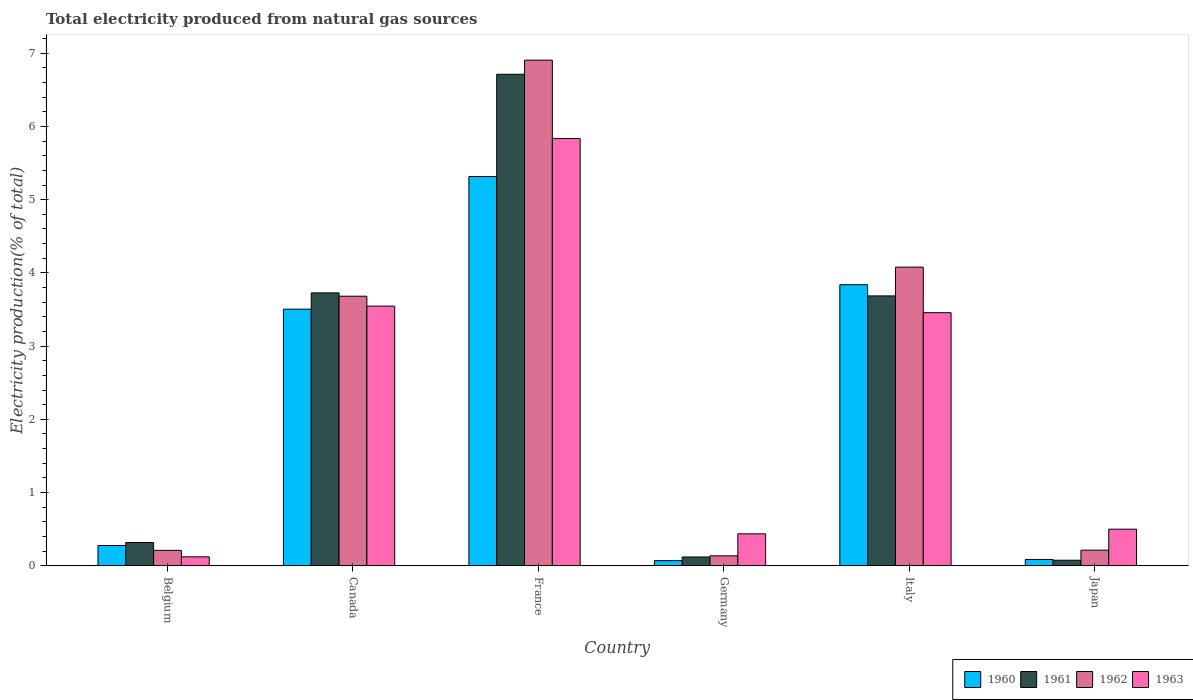How many different coloured bars are there?
Your response must be concise. 4. How many groups of bars are there?
Give a very brief answer. 6. Are the number of bars per tick equal to the number of legend labels?
Your answer should be compact. Yes. Are the number of bars on each tick of the X-axis equal?
Provide a short and direct response. Yes. How many bars are there on the 3rd tick from the left?
Your response must be concise. 4. What is the total electricity produced in 1963 in Canada?
Make the answer very short. 3.55. Across all countries, what is the maximum total electricity produced in 1960?
Your answer should be compact. 5.32. Across all countries, what is the minimum total electricity produced in 1960?
Offer a very short reply. 0.07. In which country was the total electricity produced in 1961 maximum?
Provide a short and direct response. France. In which country was the total electricity produced in 1963 minimum?
Provide a short and direct response. Belgium. What is the total total electricity produced in 1961 in the graph?
Keep it short and to the point. 14.64. What is the difference between the total electricity produced in 1962 in Belgium and that in Japan?
Ensure brevity in your answer.  -0. What is the difference between the total electricity produced in 1963 in Japan and the total electricity produced in 1962 in Germany?
Your answer should be compact. 0.36. What is the average total electricity produced in 1963 per country?
Keep it short and to the point. 2.32. What is the difference between the total electricity produced of/in 1963 and total electricity produced of/in 1961 in Italy?
Ensure brevity in your answer.  -0.23. What is the ratio of the total electricity produced in 1962 in Belgium to that in Japan?
Ensure brevity in your answer.  0.99. Is the total electricity produced in 1961 in Belgium less than that in Italy?
Give a very brief answer. Yes. What is the difference between the highest and the second highest total electricity produced in 1963?
Ensure brevity in your answer.  -0.09. What is the difference between the highest and the lowest total electricity produced in 1962?
Keep it short and to the point. 6.77. Is the sum of the total electricity produced in 1961 in Belgium and Germany greater than the maximum total electricity produced in 1962 across all countries?
Make the answer very short. No. What does the 4th bar from the right in Japan represents?
Your response must be concise. 1960. How many bars are there?
Give a very brief answer. 24. Are all the bars in the graph horizontal?
Offer a very short reply. No. How many countries are there in the graph?
Give a very brief answer. 6. Are the values on the major ticks of Y-axis written in scientific E-notation?
Make the answer very short. No. Where does the legend appear in the graph?
Your answer should be very brief. Bottom right. How many legend labels are there?
Keep it short and to the point. 4. How are the legend labels stacked?
Ensure brevity in your answer.  Horizontal. What is the title of the graph?
Provide a short and direct response. Total electricity produced from natural gas sources. What is the Electricity production(% of total) in 1960 in Belgium?
Provide a short and direct response. 0.28. What is the Electricity production(% of total) in 1961 in Belgium?
Your answer should be compact. 0.32. What is the Electricity production(% of total) in 1962 in Belgium?
Keep it short and to the point. 0.21. What is the Electricity production(% of total) in 1963 in Belgium?
Keep it short and to the point. 0.12. What is the Electricity production(% of total) of 1960 in Canada?
Keep it short and to the point. 3.5. What is the Electricity production(% of total) in 1961 in Canada?
Your answer should be compact. 3.73. What is the Electricity production(% of total) in 1962 in Canada?
Offer a very short reply. 3.68. What is the Electricity production(% of total) of 1963 in Canada?
Keep it short and to the point. 3.55. What is the Electricity production(% of total) of 1960 in France?
Provide a succinct answer. 5.32. What is the Electricity production(% of total) of 1961 in France?
Your answer should be very brief. 6.71. What is the Electricity production(% of total) of 1962 in France?
Provide a short and direct response. 6.91. What is the Electricity production(% of total) in 1963 in France?
Your answer should be compact. 5.83. What is the Electricity production(% of total) of 1960 in Germany?
Make the answer very short. 0.07. What is the Electricity production(% of total) of 1961 in Germany?
Your answer should be very brief. 0.12. What is the Electricity production(% of total) in 1962 in Germany?
Give a very brief answer. 0.14. What is the Electricity production(% of total) of 1963 in Germany?
Provide a short and direct response. 0.44. What is the Electricity production(% of total) of 1960 in Italy?
Your response must be concise. 3.84. What is the Electricity production(% of total) in 1961 in Italy?
Your response must be concise. 3.69. What is the Electricity production(% of total) in 1962 in Italy?
Provide a succinct answer. 4.08. What is the Electricity production(% of total) in 1963 in Italy?
Your answer should be compact. 3.46. What is the Electricity production(% of total) of 1960 in Japan?
Provide a short and direct response. 0.09. What is the Electricity production(% of total) in 1961 in Japan?
Ensure brevity in your answer.  0.08. What is the Electricity production(% of total) of 1962 in Japan?
Your answer should be compact. 0.21. What is the Electricity production(% of total) in 1963 in Japan?
Keep it short and to the point. 0.5. Across all countries, what is the maximum Electricity production(% of total) in 1960?
Make the answer very short. 5.32. Across all countries, what is the maximum Electricity production(% of total) of 1961?
Offer a terse response. 6.71. Across all countries, what is the maximum Electricity production(% of total) of 1962?
Provide a short and direct response. 6.91. Across all countries, what is the maximum Electricity production(% of total) of 1963?
Your answer should be compact. 5.83. Across all countries, what is the minimum Electricity production(% of total) in 1960?
Your response must be concise. 0.07. Across all countries, what is the minimum Electricity production(% of total) in 1961?
Keep it short and to the point. 0.08. Across all countries, what is the minimum Electricity production(% of total) of 1962?
Your answer should be compact. 0.14. Across all countries, what is the minimum Electricity production(% of total) in 1963?
Offer a very short reply. 0.12. What is the total Electricity production(% of total) of 1960 in the graph?
Provide a short and direct response. 13.09. What is the total Electricity production(% of total) of 1961 in the graph?
Offer a terse response. 14.64. What is the total Electricity production(% of total) of 1962 in the graph?
Keep it short and to the point. 15.23. What is the total Electricity production(% of total) in 1963 in the graph?
Your answer should be very brief. 13.9. What is the difference between the Electricity production(% of total) of 1960 in Belgium and that in Canada?
Provide a short and direct response. -3.23. What is the difference between the Electricity production(% of total) of 1961 in Belgium and that in Canada?
Give a very brief answer. -3.41. What is the difference between the Electricity production(% of total) of 1962 in Belgium and that in Canada?
Offer a terse response. -3.47. What is the difference between the Electricity production(% of total) in 1963 in Belgium and that in Canada?
Make the answer very short. -3.42. What is the difference between the Electricity production(% of total) in 1960 in Belgium and that in France?
Your response must be concise. -5.04. What is the difference between the Electricity production(% of total) in 1961 in Belgium and that in France?
Offer a terse response. -6.39. What is the difference between the Electricity production(% of total) in 1962 in Belgium and that in France?
Your answer should be very brief. -6.69. What is the difference between the Electricity production(% of total) of 1963 in Belgium and that in France?
Make the answer very short. -5.71. What is the difference between the Electricity production(% of total) in 1960 in Belgium and that in Germany?
Offer a terse response. 0.21. What is the difference between the Electricity production(% of total) in 1961 in Belgium and that in Germany?
Provide a succinct answer. 0.2. What is the difference between the Electricity production(% of total) of 1962 in Belgium and that in Germany?
Offer a very short reply. 0.07. What is the difference between the Electricity production(% of total) in 1963 in Belgium and that in Germany?
Your answer should be very brief. -0.31. What is the difference between the Electricity production(% of total) of 1960 in Belgium and that in Italy?
Provide a succinct answer. -3.56. What is the difference between the Electricity production(% of total) of 1961 in Belgium and that in Italy?
Ensure brevity in your answer.  -3.37. What is the difference between the Electricity production(% of total) in 1962 in Belgium and that in Italy?
Your answer should be very brief. -3.87. What is the difference between the Electricity production(% of total) of 1963 in Belgium and that in Italy?
Your answer should be very brief. -3.33. What is the difference between the Electricity production(% of total) of 1960 in Belgium and that in Japan?
Your answer should be compact. 0.19. What is the difference between the Electricity production(% of total) in 1961 in Belgium and that in Japan?
Offer a terse response. 0.24. What is the difference between the Electricity production(% of total) in 1962 in Belgium and that in Japan?
Provide a short and direct response. -0. What is the difference between the Electricity production(% of total) in 1963 in Belgium and that in Japan?
Your answer should be compact. -0.38. What is the difference between the Electricity production(% of total) in 1960 in Canada and that in France?
Give a very brief answer. -1.81. What is the difference between the Electricity production(% of total) in 1961 in Canada and that in France?
Make the answer very short. -2.99. What is the difference between the Electricity production(% of total) of 1962 in Canada and that in France?
Offer a very short reply. -3.22. What is the difference between the Electricity production(% of total) in 1963 in Canada and that in France?
Your answer should be compact. -2.29. What is the difference between the Electricity production(% of total) of 1960 in Canada and that in Germany?
Make the answer very short. 3.43. What is the difference between the Electricity production(% of total) of 1961 in Canada and that in Germany?
Keep it short and to the point. 3.61. What is the difference between the Electricity production(% of total) of 1962 in Canada and that in Germany?
Offer a terse response. 3.55. What is the difference between the Electricity production(% of total) of 1963 in Canada and that in Germany?
Ensure brevity in your answer.  3.11. What is the difference between the Electricity production(% of total) of 1960 in Canada and that in Italy?
Give a very brief answer. -0.33. What is the difference between the Electricity production(% of total) in 1961 in Canada and that in Italy?
Your answer should be very brief. 0.04. What is the difference between the Electricity production(% of total) of 1962 in Canada and that in Italy?
Keep it short and to the point. -0.4. What is the difference between the Electricity production(% of total) of 1963 in Canada and that in Italy?
Provide a short and direct response. 0.09. What is the difference between the Electricity production(% of total) in 1960 in Canada and that in Japan?
Give a very brief answer. 3.42. What is the difference between the Electricity production(% of total) in 1961 in Canada and that in Japan?
Make the answer very short. 3.65. What is the difference between the Electricity production(% of total) in 1962 in Canada and that in Japan?
Give a very brief answer. 3.47. What is the difference between the Electricity production(% of total) of 1963 in Canada and that in Japan?
Offer a very short reply. 3.05. What is the difference between the Electricity production(% of total) in 1960 in France and that in Germany?
Make the answer very short. 5.25. What is the difference between the Electricity production(% of total) in 1961 in France and that in Germany?
Your answer should be compact. 6.59. What is the difference between the Electricity production(% of total) of 1962 in France and that in Germany?
Offer a terse response. 6.77. What is the difference between the Electricity production(% of total) of 1963 in France and that in Germany?
Offer a very short reply. 5.4. What is the difference between the Electricity production(% of total) of 1960 in France and that in Italy?
Provide a short and direct response. 1.48. What is the difference between the Electricity production(% of total) of 1961 in France and that in Italy?
Your answer should be very brief. 3.03. What is the difference between the Electricity production(% of total) in 1962 in France and that in Italy?
Offer a very short reply. 2.83. What is the difference between the Electricity production(% of total) in 1963 in France and that in Italy?
Offer a terse response. 2.38. What is the difference between the Electricity production(% of total) in 1960 in France and that in Japan?
Provide a short and direct response. 5.23. What is the difference between the Electricity production(% of total) of 1961 in France and that in Japan?
Give a very brief answer. 6.64. What is the difference between the Electricity production(% of total) in 1962 in France and that in Japan?
Your answer should be compact. 6.69. What is the difference between the Electricity production(% of total) of 1963 in France and that in Japan?
Offer a very short reply. 5.33. What is the difference between the Electricity production(% of total) in 1960 in Germany and that in Italy?
Your answer should be very brief. -3.77. What is the difference between the Electricity production(% of total) in 1961 in Germany and that in Italy?
Offer a very short reply. -3.57. What is the difference between the Electricity production(% of total) of 1962 in Germany and that in Italy?
Give a very brief answer. -3.94. What is the difference between the Electricity production(% of total) of 1963 in Germany and that in Italy?
Ensure brevity in your answer.  -3.02. What is the difference between the Electricity production(% of total) of 1960 in Germany and that in Japan?
Offer a very short reply. -0.02. What is the difference between the Electricity production(% of total) of 1961 in Germany and that in Japan?
Your answer should be compact. 0.04. What is the difference between the Electricity production(% of total) in 1962 in Germany and that in Japan?
Ensure brevity in your answer.  -0.08. What is the difference between the Electricity production(% of total) of 1963 in Germany and that in Japan?
Offer a terse response. -0.06. What is the difference between the Electricity production(% of total) in 1960 in Italy and that in Japan?
Make the answer very short. 3.75. What is the difference between the Electricity production(% of total) in 1961 in Italy and that in Japan?
Keep it short and to the point. 3.61. What is the difference between the Electricity production(% of total) of 1962 in Italy and that in Japan?
Provide a short and direct response. 3.86. What is the difference between the Electricity production(% of total) in 1963 in Italy and that in Japan?
Offer a very short reply. 2.96. What is the difference between the Electricity production(% of total) in 1960 in Belgium and the Electricity production(% of total) in 1961 in Canada?
Keep it short and to the point. -3.45. What is the difference between the Electricity production(% of total) of 1960 in Belgium and the Electricity production(% of total) of 1962 in Canada?
Offer a terse response. -3.4. What is the difference between the Electricity production(% of total) of 1960 in Belgium and the Electricity production(% of total) of 1963 in Canada?
Your answer should be very brief. -3.27. What is the difference between the Electricity production(% of total) of 1961 in Belgium and the Electricity production(% of total) of 1962 in Canada?
Make the answer very short. -3.36. What is the difference between the Electricity production(% of total) of 1961 in Belgium and the Electricity production(% of total) of 1963 in Canada?
Give a very brief answer. -3.23. What is the difference between the Electricity production(% of total) in 1962 in Belgium and the Electricity production(% of total) in 1963 in Canada?
Provide a short and direct response. -3.34. What is the difference between the Electricity production(% of total) of 1960 in Belgium and the Electricity production(% of total) of 1961 in France?
Your answer should be very brief. -6.43. What is the difference between the Electricity production(% of total) in 1960 in Belgium and the Electricity production(% of total) in 1962 in France?
Your answer should be very brief. -6.63. What is the difference between the Electricity production(% of total) of 1960 in Belgium and the Electricity production(% of total) of 1963 in France?
Provide a succinct answer. -5.56. What is the difference between the Electricity production(% of total) of 1961 in Belgium and the Electricity production(% of total) of 1962 in France?
Give a very brief answer. -6.59. What is the difference between the Electricity production(% of total) of 1961 in Belgium and the Electricity production(% of total) of 1963 in France?
Your answer should be compact. -5.52. What is the difference between the Electricity production(% of total) in 1962 in Belgium and the Electricity production(% of total) in 1963 in France?
Ensure brevity in your answer.  -5.62. What is the difference between the Electricity production(% of total) of 1960 in Belgium and the Electricity production(% of total) of 1961 in Germany?
Your response must be concise. 0.16. What is the difference between the Electricity production(% of total) in 1960 in Belgium and the Electricity production(% of total) in 1962 in Germany?
Your answer should be very brief. 0.14. What is the difference between the Electricity production(% of total) of 1960 in Belgium and the Electricity production(% of total) of 1963 in Germany?
Your answer should be compact. -0.16. What is the difference between the Electricity production(% of total) in 1961 in Belgium and the Electricity production(% of total) in 1962 in Germany?
Offer a very short reply. 0.18. What is the difference between the Electricity production(% of total) in 1961 in Belgium and the Electricity production(% of total) in 1963 in Germany?
Make the answer very short. -0.12. What is the difference between the Electricity production(% of total) of 1962 in Belgium and the Electricity production(% of total) of 1963 in Germany?
Your answer should be very brief. -0.23. What is the difference between the Electricity production(% of total) in 1960 in Belgium and the Electricity production(% of total) in 1961 in Italy?
Ensure brevity in your answer.  -3.41. What is the difference between the Electricity production(% of total) in 1960 in Belgium and the Electricity production(% of total) in 1962 in Italy?
Make the answer very short. -3.8. What is the difference between the Electricity production(% of total) of 1960 in Belgium and the Electricity production(% of total) of 1963 in Italy?
Make the answer very short. -3.18. What is the difference between the Electricity production(% of total) of 1961 in Belgium and the Electricity production(% of total) of 1962 in Italy?
Keep it short and to the point. -3.76. What is the difference between the Electricity production(% of total) in 1961 in Belgium and the Electricity production(% of total) in 1963 in Italy?
Your response must be concise. -3.14. What is the difference between the Electricity production(% of total) in 1962 in Belgium and the Electricity production(% of total) in 1963 in Italy?
Make the answer very short. -3.25. What is the difference between the Electricity production(% of total) in 1960 in Belgium and the Electricity production(% of total) in 1961 in Japan?
Give a very brief answer. 0.2. What is the difference between the Electricity production(% of total) in 1960 in Belgium and the Electricity production(% of total) in 1962 in Japan?
Offer a terse response. 0.06. What is the difference between the Electricity production(% of total) of 1960 in Belgium and the Electricity production(% of total) of 1963 in Japan?
Make the answer very short. -0.22. What is the difference between the Electricity production(% of total) of 1961 in Belgium and the Electricity production(% of total) of 1962 in Japan?
Give a very brief answer. 0.1. What is the difference between the Electricity production(% of total) of 1961 in Belgium and the Electricity production(% of total) of 1963 in Japan?
Your response must be concise. -0.18. What is the difference between the Electricity production(% of total) of 1962 in Belgium and the Electricity production(% of total) of 1963 in Japan?
Make the answer very short. -0.29. What is the difference between the Electricity production(% of total) of 1960 in Canada and the Electricity production(% of total) of 1961 in France?
Your response must be concise. -3.21. What is the difference between the Electricity production(% of total) in 1960 in Canada and the Electricity production(% of total) in 1962 in France?
Offer a very short reply. -3.4. What is the difference between the Electricity production(% of total) in 1960 in Canada and the Electricity production(% of total) in 1963 in France?
Your answer should be compact. -2.33. What is the difference between the Electricity production(% of total) of 1961 in Canada and the Electricity production(% of total) of 1962 in France?
Your answer should be compact. -3.18. What is the difference between the Electricity production(% of total) of 1961 in Canada and the Electricity production(% of total) of 1963 in France?
Ensure brevity in your answer.  -2.11. What is the difference between the Electricity production(% of total) of 1962 in Canada and the Electricity production(% of total) of 1963 in France?
Provide a short and direct response. -2.15. What is the difference between the Electricity production(% of total) in 1960 in Canada and the Electricity production(% of total) in 1961 in Germany?
Make the answer very short. 3.38. What is the difference between the Electricity production(% of total) of 1960 in Canada and the Electricity production(% of total) of 1962 in Germany?
Provide a short and direct response. 3.37. What is the difference between the Electricity production(% of total) of 1960 in Canada and the Electricity production(% of total) of 1963 in Germany?
Your answer should be very brief. 3.07. What is the difference between the Electricity production(% of total) in 1961 in Canada and the Electricity production(% of total) in 1962 in Germany?
Give a very brief answer. 3.59. What is the difference between the Electricity production(% of total) in 1961 in Canada and the Electricity production(% of total) in 1963 in Germany?
Keep it short and to the point. 3.29. What is the difference between the Electricity production(% of total) of 1962 in Canada and the Electricity production(% of total) of 1963 in Germany?
Keep it short and to the point. 3.25. What is the difference between the Electricity production(% of total) of 1960 in Canada and the Electricity production(% of total) of 1961 in Italy?
Keep it short and to the point. -0.18. What is the difference between the Electricity production(% of total) in 1960 in Canada and the Electricity production(% of total) in 1962 in Italy?
Offer a terse response. -0.57. What is the difference between the Electricity production(% of total) of 1960 in Canada and the Electricity production(% of total) of 1963 in Italy?
Keep it short and to the point. 0.05. What is the difference between the Electricity production(% of total) in 1961 in Canada and the Electricity production(% of total) in 1962 in Italy?
Your answer should be very brief. -0.35. What is the difference between the Electricity production(% of total) of 1961 in Canada and the Electricity production(% of total) of 1963 in Italy?
Ensure brevity in your answer.  0.27. What is the difference between the Electricity production(% of total) in 1962 in Canada and the Electricity production(% of total) in 1963 in Italy?
Offer a terse response. 0.23. What is the difference between the Electricity production(% of total) of 1960 in Canada and the Electricity production(% of total) of 1961 in Japan?
Provide a succinct answer. 3.43. What is the difference between the Electricity production(% of total) in 1960 in Canada and the Electricity production(% of total) in 1962 in Japan?
Make the answer very short. 3.29. What is the difference between the Electricity production(% of total) of 1960 in Canada and the Electricity production(% of total) of 1963 in Japan?
Ensure brevity in your answer.  3. What is the difference between the Electricity production(% of total) in 1961 in Canada and the Electricity production(% of total) in 1962 in Japan?
Your answer should be compact. 3.51. What is the difference between the Electricity production(% of total) of 1961 in Canada and the Electricity production(% of total) of 1963 in Japan?
Provide a short and direct response. 3.23. What is the difference between the Electricity production(% of total) in 1962 in Canada and the Electricity production(% of total) in 1963 in Japan?
Keep it short and to the point. 3.18. What is the difference between the Electricity production(% of total) in 1960 in France and the Electricity production(% of total) in 1961 in Germany?
Your response must be concise. 5.2. What is the difference between the Electricity production(% of total) of 1960 in France and the Electricity production(% of total) of 1962 in Germany?
Provide a short and direct response. 5.18. What is the difference between the Electricity production(% of total) of 1960 in France and the Electricity production(% of total) of 1963 in Germany?
Your response must be concise. 4.88. What is the difference between the Electricity production(% of total) of 1961 in France and the Electricity production(% of total) of 1962 in Germany?
Your answer should be very brief. 6.58. What is the difference between the Electricity production(% of total) of 1961 in France and the Electricity production(% of total) of 1963 in Germany?
Give a very brief answer. 6.28. What is the difference between the Electricity production(% of total) of 1962 in France and the Electricity production(% of total) of 1963 in Germany?
Provide a succinct answer. 6.47. What is the difference between the Electricity production(% of total) of 1960 in France and the Electricity production(% of total) of 1961 in Italy?
Provide a short and direct response. 1.63. What is the difference between the Electricity production(% of total) in 1960 in France and the Electricity production(% of total) in 1962 in Italy?
Ensure brevity in your answer.  1.24. What is the difference between the Electricity production(% of total) of 1960 in France and the Electricity production(% of total) of 1963 in Italy?
Give a very brief answer. 1.86. What is the difference between the Electricity production(% of total) of 1961 in France and the Electricity production(% of total) of 1962 in Italy?
Ensure brevity in your answer.  2.63. What is the difference between the Electricity production(% of total) in 1961 in France and the Electricity production(% of total) in 1963 in Italy?
Your answer should be compact. 3.26. What is the difference between the Electricity production(% of total) of 1962 in France and the Electricity production(% of total) of 1963 in Italy?
Keep it short and to the point. 3.45. What is the difference between the Electricity production(% of total) in 1960 in France and the Electricity production(% of total) in 1961 in Japan?
Make the answer very short. 5.24. What is the difference between the Electricity production(% of total) of 1960 in France and the Electricity production(% of total) of 1962 in Japan?
Offer a terse response. 5.1. What is the difference between the Electricity production(% of total) of 1960 in France and the Electricity production(% of total) of 1963 in Japan?
Your answer should be very brief. 4.82. What is the difference between the Electricity production(% of total) in 1961 in France and the Electricity production(% of total) in 1962 in Japan?
Your answer should be compact. 6.5. What is the difference between the Electricity production(% of total) of 1961 in France and the Electricity production(% of total) of 1963 in Japan?
Your answer should be very brief. 6.21. What is the difference between the Electricity production(% of total) in 1962 in France and the Electricity production(% of total) in 1963 in Japan?
Your answer should be very brief. 6.4. What is the difference between the Electricity production(% of total) in 1960 in Germany and the Electricity production(% of total) in 1961 in Italy?
Your response must be concise. -3.62. What is the difference between the Electricity production(% of total) in 1960 in Germany and the Electricity production(% of total) in 1962 in Italy?
Give a very brief answer. -4.01. What is the difference between the Electricity production(% of total) of 1960 in Germany and the Electricity production(% of total) of 1963 in Italy?
Offer a very short reply. -3.39. What is the difference between the Electricity production(% of total) in 1961 in Germany and the Electricity production(% of total) in 1962 in Italy?
Offer a very short reply. -3.96. What is the difference between the Electricity production(% of total) of 1961 in Germany and the Electricity production(% of total) of 1963 in Italy?
Offer a very short reply. -3.34. What is the difference between the Electricity production(% of total) of 1962 in Germany and the Electricity production(% of total) of 1963 in Italy?
Offer a terse response. -3.32. What is the difference between the Electricity production(% of total) of 1960 in Germany and the Electricity production(% of total) of 1961 in Japan?
Your response must be concise. -0.01. What is the difference between the Electricity production(% of total) in 1960 in Germany and the Electricity production(% of total) in 1962 in Japan?
Ensure brevity in your answer.  -0.14. What is the difference between the Electricity production(% of total) in 1960 in Germany and the Electricity production(% of total) in 1963 in Japan?
Give a very brief answer. -0.43. What is the difference between the Electricity production(% of total) in 1961 in Germany and the Electricity production(% of total) in 1962 in Japan?
Ensure brevity in your answer.  -0.09. What is the difference between the Electricity production(% of total) in 1961 in Germany and the Electricity production(% of total) in 1963 in Japan?
Ensure brevity in your answer.  -0.38. What is the difference between the Electricity production(% of total) of 1962 in Germany and the Electricity production(% of total) of 1963 in Japan?
Provide a succinct answer. -0.36. What is the difference between the Electricity production(% of total) in 1960 in Italy and the Electricity production(% of total) in 1961 in Japan?
Provide a short and direct response. 3.76. What is the difference between the Electricity production(% of total) of 1960 in Italy and the Electricity production(% of total) of 1962 in Japan?
Your answer should be compact. 3.62. What is the difference between the Electricity production(% of total) in 1960 in Italy and the Electricity production(% of total) in 1963 in Japan?
Your response must be concise. 3.34. What is the difference between the Electricity production(% of total) of 1961 in Italy and the Electricity production(% of total) of 1962 in Japan?
Keep it short and to the point. 3.47. What is the difference between the Electricity production(% of total) in 1961 in Italy and the Electricity production(% of total) in 1963 in Japan?
Provide a succinct answer. 3.19. What is the difference between the Electricity production(% of total) in 1962 in Italy and the Electricity production(% of total) in 1963 in Japan?
Make the answer very short. 3.58. What is the average Electricity production(% of total) in 1960 per country?
Offer a very short reply. 2.18. What is the average Electricity production(% of total) in 1961 per country?
Your answer should be compact. 2.44. What is the average Electricity production(% of total) of 1962 per country?
Your response must be concise. 2.54. What is the average Electricity production(% of total) of 1963 per country?
Make the answer very short. 2.32. What is the difference between the Electricity production(% of total) in 1960 and Electricity production(% of total) in 1961 in Belgium?
Make the answer very short. -0.04. What is the difference between the Electricity production(% of total) in 1960 and Electricity production(% of total) in 1962 in Belgium?
Provide a succinct answer. 0.07. What is the difference between the Electricity production(% of total) of 1960 and Electricity production(% of total) of 1963 in Belgium?
Your answer should be very brief. 0.15. What is the difference between the Electricity production(% of total) of 1961 and Electricity production(% of total) of 1962 in Belgium?
Your response must be concise. 0.11. What is the difference between the Electricity production(% of total) in 1961 and Electricity production(% of total) in 1963 in Belgium?
Provide a short and direct response. 0.2. What is the difference between the Electricity production(% of total) of 1962 and Electricity production(% of total) of 1963 in Belgium?
Make the answer very short. 0.09. What is the difference between the Electricity production(% of total) in 1960 and Electricity production(% of total) in 1961 in Canada?
Ensure brevity in your answer.  -0.22. What is the difference between the Electricity production(% of total) in 1960 and Electricity production(% of total) in 1962 in Canada?
Provide a succinct answer. -0.18. What is the difference between the Electricity production(% of total) in 1960 and Electricity production(% of total) in 1963 in Canada?
Provide a short and direct response. -0.04. What is the difference between the Electricity production(% of total) in 1961 and Electricity production(% of total) in 1962 in Canada?
Offer a terse response. 0.05. What is the difference between the Electricity production(% of total) in 1961 and Electricity production(% of total) in 1963 in Canada?
Offer a very short reply. 0.18. What is the difference between the Electricity production(% of total) of 1962 and Electricity production(% of total) of 1963 in Canada?
Give a very brief answer. 0.14. What is the difference between the Electricity production(% of total) in 1960 and Electricity production(% of total) in 1961 in France?
Offer a very short reply. -1.4. What is the difference between the Electricity production(% of total) of 1960 and Electricity production(% of total) of 1962 in France?
Give a very brief answer. -1.59. What is the difference between the Electricity production(% of total) in 1960 and Electricity production(% of total) in 1963 in France?
Make the answer very short. -0.52. What is the difference between the Electricity production(% of total) of 1961 and Electricity production(% of total) of 1962 in France?
Your response must be concise. -0.19. What is the difference between the Electricity production(% of total) of 1961 and Electricity production(% of total) of 1963 in France?
Offer a very short reply. 0.88. What is the difference between the Electricity production(% of total) in 1962 and Electricity production(% of total) in 1963 in France?
Make the answer very short. 1.07. What is the difference between the Electricity production(% of total) of 1960 and Electricity production(% of total) of 1961 in Germany?
Provide a short and direct response. -0.05. What is the difference between the Electricity production(% of total) of 1960 and Electricity production(% of total) of 1962 in Germany?
Ensure brevity in your answer.  -0.07. What is the difference between the Electricity production(% of total) in 1960 and Electricity production(% of total) in 1963 in Germany?
Offer a very short reply. -0.37. What is the difference between the Electricity production(% of total) of 1961 and Electricity production(% of total) of 1962 in Germany?
Provide a short and direct response. -0.02. What is the difference between the Electricity production(% of total) in 1961 and Electricity production(% of total) in 1963 in Germany?
Provide a short and direct response. -0.32. What is the difference between the Electricity production(% of total) in 1962 and Electricity production(% of total) in 1963 in Germany?
Your response must be concise. -0.3. What is the difference between the Electricity production(% of total) of 1960 and Electricity production(% of total) of 1961 in Italy?
Your answer should be compact. 0.15. What is the difference between the Electricity production(% of total) in 1960 and Electricity production(% of total) in 1962 in Italy?
Provide a succinct answer. -0.24. What is the difference between the Electricity production(% of total) in 1960 and Electricity production(% of total) in 1963 in Italy?
Offer a very short reply. 0.38. What is the difference between the Electricity production(% of total) in 1961 and Electricity production(% of total) in 1962 in Italy?
Keep it short and to the point. -0.39. What is the difference between the Electricity production(% of total) in 1961 and Electricity production(% of total) in 1963 in Italy?
Provide a short and direct response. 0.23. What is the difference between the Electricity production(% of total) in 1962 and Electricity production(% of total) in 1963 in Italy?
Offer a terse response. 0.62. What is the difference between the Electricity production(% of total) in 1960 and Electricity production(% of total) in 1961 in Japan?
Your response must be concise. 0.01. What is the difference between the Electricity production(% of total) of 1960 and Electricity production(% of total) of 1962 in Japan?
Offer a terse response. -0.13. What is the difference between the Electricity production(% of total) in 1960 and Electricity production(% of total) in 1963 in Japan?
Your answer should be very brief. -0.41. What is the difference between the Electricity production(% of total) of 1961 and Electricity production(% of total) of 1962 in Japan?
Ensure brevity in your answer.  -0.14. What is the difference between the Electricity production(% of total) in 1961 and Electricity production(% of total) in 1963 in Japan?
Give a very brief answer. -0.42. What is the difference between the Electricity production(% of total) of 1962 and Electricity production(% of total) of 1963 in Japan?
Give a very brief answer. -0.29. What is the ratio of the Electricity production(% of total) in 1960 in Belgium to that in Canada?
Ensure brevity in your answer.  0.08. What is the ratio of the Electricity production(% of total) in 1961 in Belgium to that in Canada?
Offer a very short reply. 0.09. What is the ratio of the Electricity production(% of total) of 1962 in Belgium to that in Canada?
Provide a short and direct response. 0.06. What is the ratio of the Electricity production(% of total) of 1963 in Belgium to that in Canada?
Provide a short and direct response. 0.03. What is the ratio of the Electricity production(% of total) in 1960 in Belgium to that in France?
Keep it short and to the point. 0.05. What is the ratio of the Electricity production(% of total) in 1961 in Belgium to that in France?
Make the answer very short. 0.05. What is the ratio of the Electricity production(% of total) in 1962 in Belgium to that in France?
Offer a terse response. 0.03. What is the ratio of the Electricity production(% of total) in 1963 in Belgium to that in France?
Keep it short and to the point. 0.02. What is the ratio of the Electricity production(% of total) in 1960 in Belgium to that in Germany?
Provide a succinct answer. 3.94. What is the ratio of the Electricity production(% of total) of 1961 in Belgium to that in Germany?
Provide a succinct answer. 2.64. What is the ratio of the Electricity production(% of total) in 1962 in Belgium to that in Germany?
Provide a short and direct response. 1.55. What is the ratio of the Electricity production(% of total) in 1963 in Belgium to that in Germany?
Provide a short and direct response. 0.28. What is the ratio of the Electricity production(% of total) of 1960 in Belgium to that in Italy?
Offer a terse response. 0.07. What is the ratio of the Electricity production(% of total) of 1961 in Belgium to that in Italy?
Keep it short and to the point. 0.09. What is the ratio of the Electricity production(% of total) in 1962 in Belgium to that in Italy?
Provide a short and direct response. 0.05. What is the ratio of the Electricity production(% of total) in 1963 in Belgium to that in Italy?
Your response must be concise. 0.04. What is the ratio of the Electricity production(% of total) in 1960 in Belgium to that in Japan?
Your answer should be very brief. 3.2. What is the ratio of the Electricity production(% of total) of 1961 in Belgium to that in Japan?
Your response must be concise. 4.2. What is the ratio of the Electricity production(% of total) in 1962 in Belgium to that in Japan?
Make the answer very short. 0.99. What is the ratio of the Electricity production(% of total) of 1963 in Belgium to that in Japan?
Your response must be concise. 0.24. What is the ratio of the Electricity production(% of total) in 1960 in Canada to that in France?
Provide a short and direct response. 0.66. What is the ratio of the Electricity production(% of total) in 1961 in Canada to that in France?
Provide a short and direct response. 0.56. What is the ratio of the Electricity production(% of total) of 1962 in Canada to that in France?
Provide a short and direct response. 0.53. What is the ratio of the Electricity production(% of total) of 1963 in Canada to that in France?
Make the answer very short. 0.61. What is the ratio of the Electricity production(% of total) of 1960 in Canada to that in Germany?
Give a very brief answer. 49.85. What is the ratio of the Electricity production(% of total) in 1961 in Canada to that in Germany?
Your answer should be very brief. 30.98. What is the ratio of the Electricity production(% of total) of 1962 in Canada to that in Germany?
Keep it short and to the point. 27.02. What is the ratio of the Electricity production(% of total) in 1963 in Canada to that in Germany?
Ensure brevity in your answer.  8.13. What is the ratio of the Electricity production(% of total) in 1960 in Canada to that in Italy?
Keep it short and to the point. 0.91. What is the ratio of the Electricity production(% of total) of 1961 in Canada to that in Italy?
Offer a very short reply. 1.01. What is the ratio of the Electricity production(% of total) of 1962 in Canada to that in Italy?
Ensure brevity in your answer.  0.9. What is the ratio of the Electricity production(% of total) in 1963 in Canada to that in Italy?
Give a very brief answer. 1.03. What is the ratio of the Electricity production(% of total) of 1960 in Canada to that in Japan?
Provide a succinct answer. 40.48. What is the ratio of the Electricity production(% of total) of 1961 in Canada to that in Japan?
Offer a very short reply. 49.23. What is the ratio of the Electricity production(% of total) in 1962 in Canada to that in Japan?
Provide a succinct answer. 17.23. What is the ratio of the Electricity production(% of total) of 1963 in Canada to that in Japan?
Provide a short and direct response. 7.09. What is the ratio of the Electricity production(% of total) in 1960 in France to that in Germany?
Provide a succinct answer. 75.62. What is the ratio of the Electricity production(% of total) in 1961 in France to that in Germany?
Ensure brevity in your answer.  55.79. What is the ratio of the Electricity production(% of total) in 1962 in France to that in Germany?
Give a very brief answer. 50.69. What is the ratio of the Electricity production(% of total) in 1963 in France to that in Germany?
Provide a short and direct response. 13.38. What is the ratio of the Electricity production(% of total) in 1960 in France to that in Italy?
Your answer should be very brief. 1.39. What is the ratio of the Electricity production(% of total) of 1961 in France to that in Italy?
Your answer should be compact. 1.82. What is the ratio of the Electricity production(% of total) in 1962 in France to that in Italy?
Make the answer very short. 1.69. What is the ratio of the Electricity production(% of total) in 1963 in France to that in Italy?
Provide a short and direct response. 1.69. What is the ratio of the Electricity production(% of total) of 1960 in France to that in Japan?
Offer a terse response. 61.4. What is the ratio of the Electricity production(% of total) of 1961 in France to that in Japan?
Provide a short and direct response. 88.67. What is the ratio of the Electricity production(% of total) in 1962 in France to that in Japan?
Your response must be concise. 32.32. What is the ratio of the Electricity production(% of total) in 1963 in France to that in Japan?
Provide a succinct answer. 11.67. What is the ratio of the Electricity production(% of total) of 1960 in Germany to that in Italy?
Your answer should be compact. 0.02. What is the ratio of the Electricity production(% of total) in 1961 in Germany to that in Italy?
Provide a short and direct response. 0.03. What is the ratio of the Electricity production(% of total) of 1962 in Germany to that in Italy?
Keep it short and to the point. 0.03. What is the ratio of the Electricity production(% of total) in 1963 in Germany to that in Italy?
Make the answer very short. 0.13. What is the ratio of the Electricity production(% of total) of 1960 in Germany to that in Japan?
Give a very brief answer. 0.81. What is the ratio of the Electricity production(% of total) in 1961 in Germany to that in Japan?
Your response must be concise. 1.59. What is the ratio of the Electricity production(% of total) in 1962 in Germany to that in Japan?
Offer a very short reply. 0.64. What is the ratio of the Electricity production(% of total) in 1963 in Germany to that in Japan?
Make the answer very short. 0.87. What is the ratio of the Electricity production(% of total) of 1960 in Italy to that in Japan?
Provide a succinct answer. 44.33. What is the ratio of the Electricity production(% of total) in 1961 in Italy to that in Japan?
Your answer should be very brief. 48.69. What is the ratio of the Electricity production(% of total) in 1962 in Italy to that in Japan?
Offer a very short reply. 19.09. What is the ratio of the Electricity production(% of total) of 1963 in Italy to that in Japan?
Give a very brief answer. 6.91. What is the difference between the highest and the second highest Electricity production(% of total) of 1960?
Offer a very short reply. 1.48. What is the difference between the highest and the second highest Electricity production(% of total) of 1961?
Keep it short and to the point. 2.99. What is the difference between the highest and the second highest Electricity production(% of total) of 1962?
Offer a terse response. 2.83. What is the difference between the highest and the second highest Electricity production(% of total) in 1963?
Provide a succinct answer. 2.29. What is the difference between the highest and the lowest Electricity production(% of total) of 1960?
Provide a succinct answer. 5.25. What is the difference between the highest and the lowest Electricity production(% of total) in 1961?
Offer a terse response. 6.64. What is the difference between the highest and the lowest Electricity production(% of total) of 1962?
Make the answer very short. 6.77. What is the difference between the highest and the lowest Electricity production(% of total) of 1963?
Ensure brevity in your answer.  5.71. 